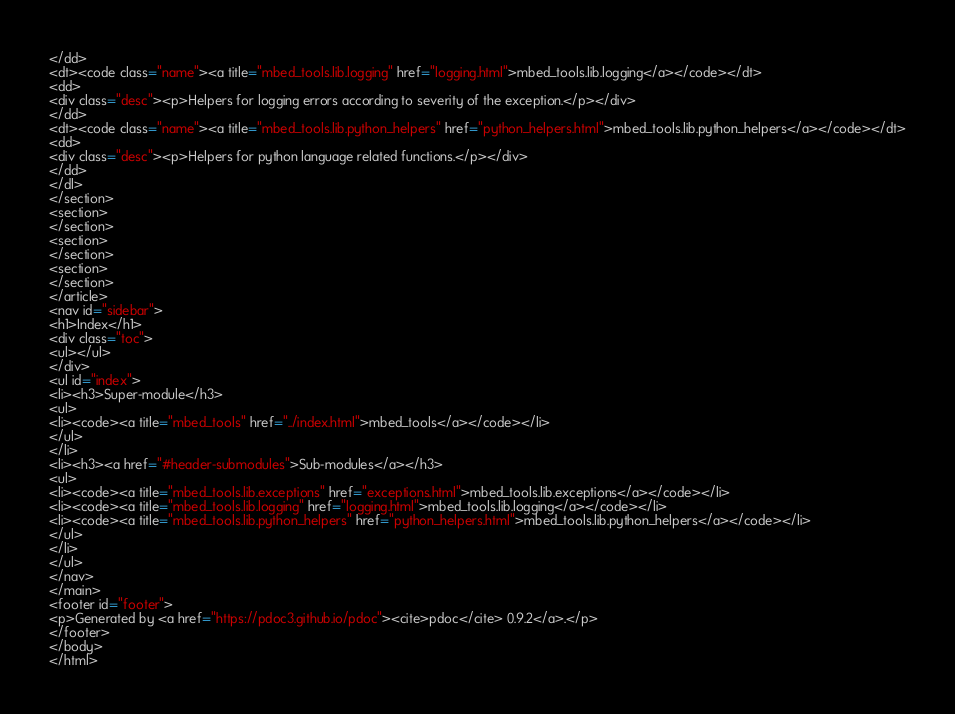Convert code to text. <code><loc_0><loc_0><loc_500><loc_500><_HTML_></dd>
<dt><code class="name"><a title="mbed_tools.lib.logging" href="logging.html">mbed_tools.lib.logging</a></code></dt>
<dd>
<div class="desc"><p>Helpers for logging errors according to severity of the exception.</p></div>
</dd>
<dt><code class="name"><a title="mbed_tools.lib.python_helpers" href="python_helpers.html">mbed_tools.lib.python_helpers</a></code></dt>
<dd>
<div class="desc"><p>Helpers for python language related functions.</p></div>
</dd>
</dl>
</section>
<section>
</section>
<section>
</section>
<section>
</section>
</article>
<nav id="sidebar">
<h1>Index</h1>
<div class="toc">
<ul></ul>
</div>
<ul id="index">
<li><h3>Super-module</h3>
<ul>
<li><code><a title="mbed_tools" href="../index.html">mbed_tools</a></code></li>
</ul>
</li>
<li><h3><a href="#header-submodules">Sub-modules</a></h3>
<ul>
<li><code><a title="mbed_tools.lib.exceptions" href="exceptions.html">mbed_tools.lib.exceptions</a></code></li>
<li><code><a title="mbed_tools.lib.logging" href="logging.html">mbed_tools.lib.logging</a></code></li>
<li><code><a title="mbed_tools.lib.python_helpers" href="python_helpers.html">mbed_tools.lib.python_helpers</a></code></li>
</ul>
</li>
</ul>
</nav>
</main>
<footer id="footer">
<p>Generated by <a href="https://pdoc3.github.io/pdoc"><cite>pdoc</cite> 0.9.2</a>.</p>
</footer>
</body>
</html></code> 